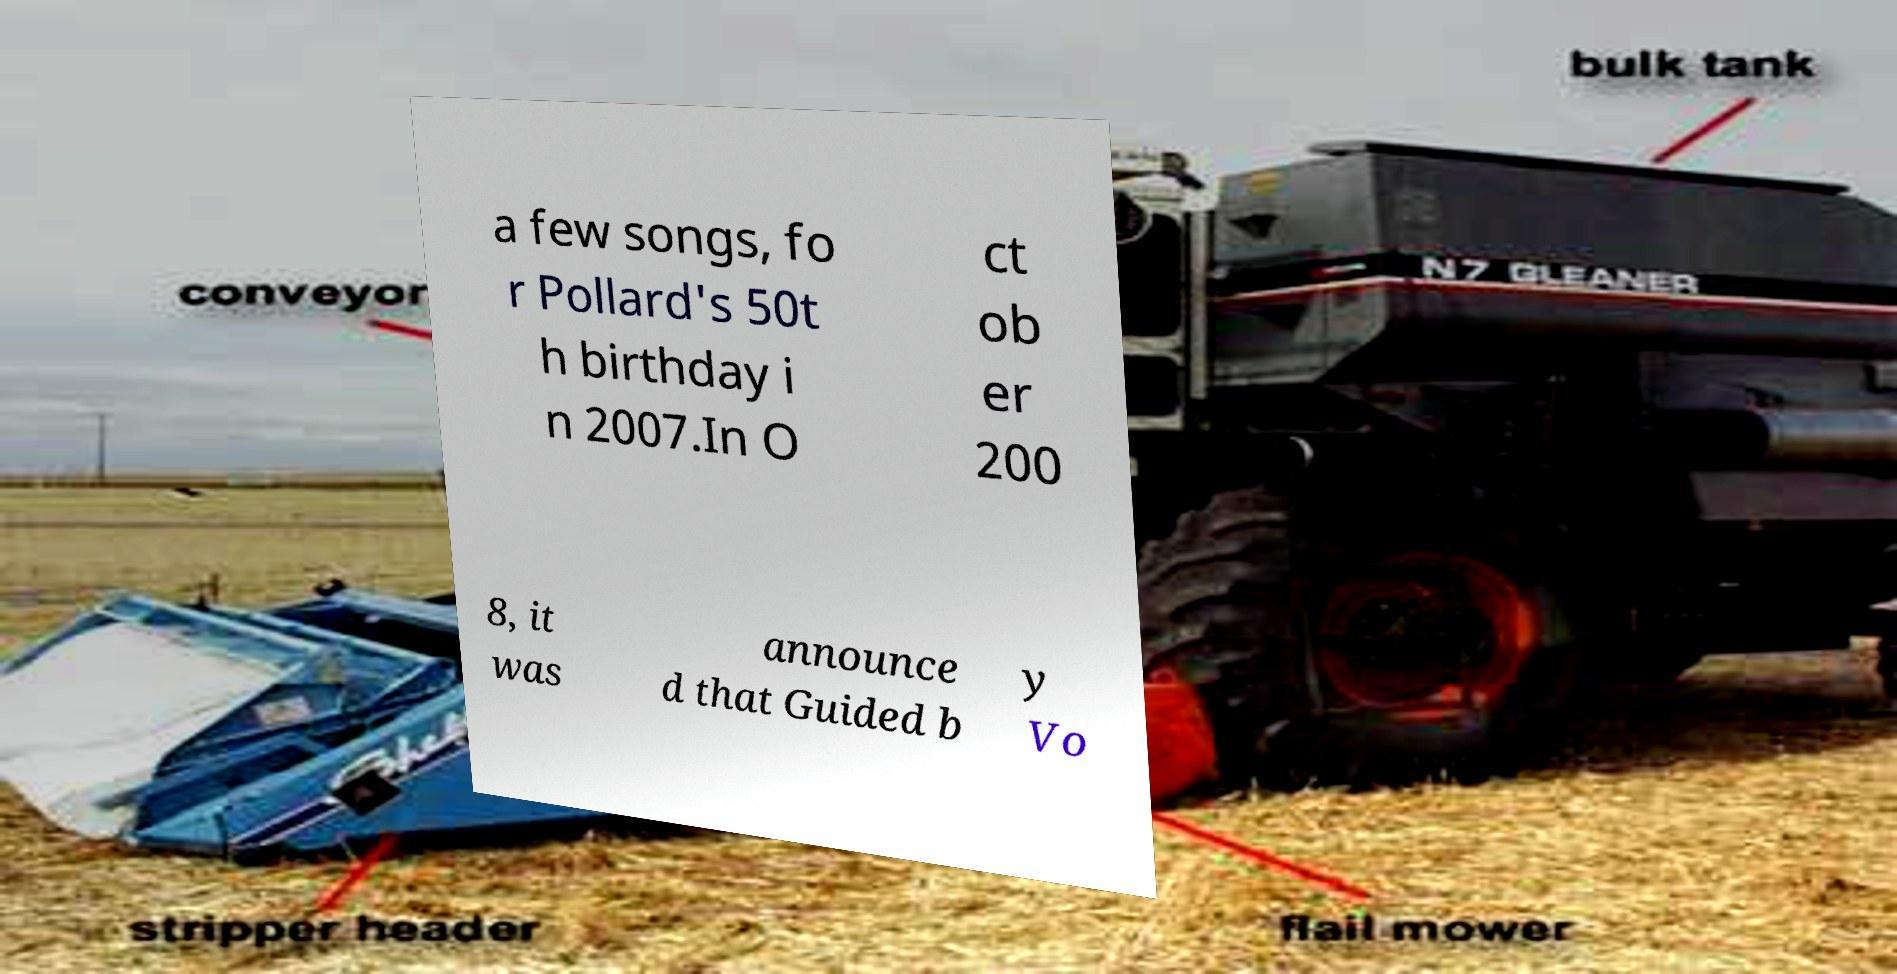There's text embedded in this image that I need extracted. Can you transcribe it verbatim? a few songs, fo r Pollard's 50t h birthday i n 2007.In O ct ob er 200 8, it was announce d that Guided b y Vo 